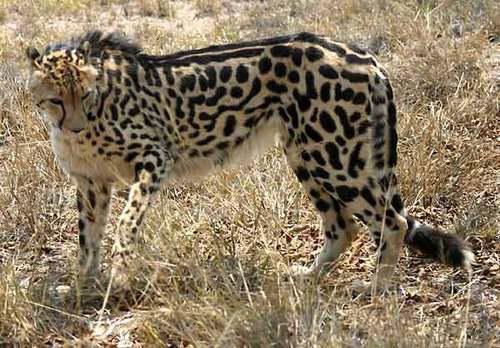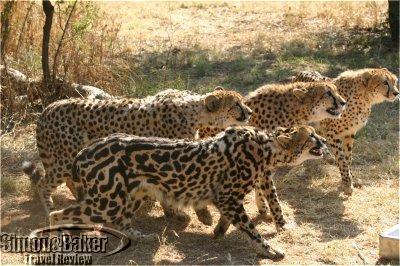The first image is the image on the left, the second image is the image on the right. Examine the images to the left and right. Is the description "The left image shows a close-mouthed cheetah with a ridge of dark hair running from its head like a mane and its body in profile." accurate? Answer yes or no. Yes. The first image is the image on the left, the second image is the image on the right. For the images shown, is this caption "There are two animals in total." true? Answer yes or no. No. 